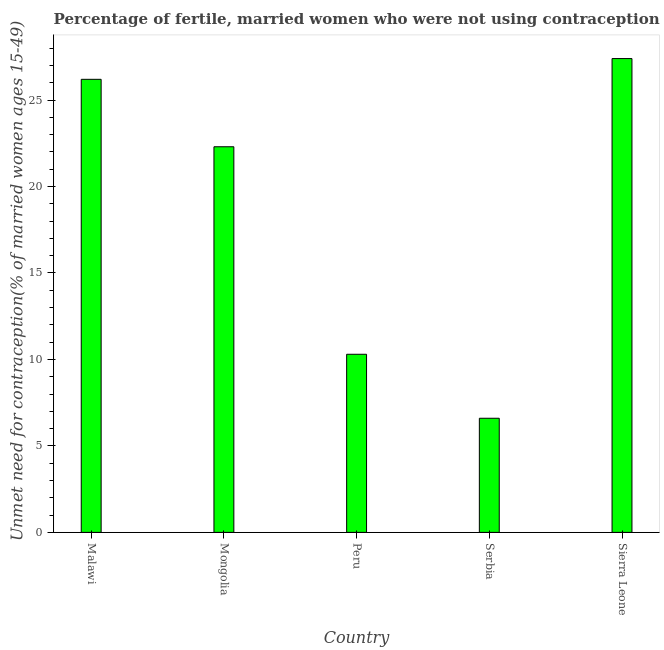Does the graph contain any zero values?
Offer a terse response. No. Does the graph contain grids?
Offer a very short reply. No. What is the title of the graph?
Your response must be concise. Percentage of fertile, married women who were not using contraception in 2010. What is the label or title of the Y-axis?
Keep it short and to the point.  Unmet need for contraception(% of married women ages 15-49). What is the number of married women who are not using contraception in Peru?
Offer a very short reply. 10.3. Across all countries, what is the maximum number of married women who are not using contraception?
Make the answer very short. 27.4. Across all countries, what is the minimum number of married women who are not using contraception?
Provide a succinct answer. 6.6. In which country was the number of married women who are not using contraception maximum?
Make the answer very short. Sierra Leone. In which country was the number of married women who are not using contraception minimum?
Your answer should be very brief. Serbia. What is the sum of the number of married women who are not using contraception?
Your response must be concise. 92.8. What is the difference between the number of married women who are not using contraception in Mongolia and Serbia?
Provide a short and direct response. 15.7. What is the average number of married women who are not using contraception per country?
Your response must be concise. 18.56. What is the median number of married women who are not using contraception?
Your answer should be compact. 22.3. In how many countries, is the number of married women who are not using contraception greater than 18 %?
Give a very brief answer. 3. What is the ratio of the number of married women who are not using contraception in Peru to that in Sierra Leone?
Provide a short and direct response. 0.38. Is the number of married women who are not using contraception in Peru less than that in Serbia?
Your answer should be compact. No. What is the difference between the highest and the lowest number of married women who are not using contraception?
Give a very brief answer. 20.8. How many countries are there in the graph?
Give a very brief answer. 5. What is the  Unmet need for contraception(% of married women ages 15-49) of Malawi?
Your answer should be compact. 26.2. What is the  Unmet need for contraception(% of married women ages 15-49) of Mongolia?
Give a very brief answer. 22.3. What is the  Unmet need for contraception(% of married women ages 15-49) in Peru?
Offer a very short reply. 10.3. What is the  Unmet need for contraception(% of married women ages 15-49) in Serbia?
Ensure brevity in your answer.  6.6. What is the  Unmet need for contraception(% of married women ages 15-49) in Sierra Leone?
Your answer should be very brief. 27.4. What is the difference between the  Unmet need for contraception(% of married women ages 15-49) in Malawi and Peru?
Offer a terse response. 15.9. What is the difference between the  Unmet need for contraception(% of married women ages 15-49) in Malawi and Serbia?
Offer a terse response. 19.6. What is the difference between the  Unmet need for contraception(% of married women ages 15-49) in Malawi and Sierra Leone?
Your answer should be very brief. -1.2. What is the difference between the  Unmet need for contraception(% of married women ages 15-49) in Mongolia and Peru?
Your answer should be very brief. 12. What is the difference between the  Unmet need for contraception(% of married women ages 15-49) in Mongolia and Sierra Leone?
Provide a succinct answer. -5.1. What is the difference between the  Unmet need for contraception(% of married women ages 15-49) in Peru and Sierra Leone?
Your answer should be compact. -17.1. What is the difference between the  Unmet need for contraception(% of married women ages 15-49) in Serbia and Sierra Leone?
Keep it short and to the point. -20.8. What is the ratio of the  Unmet need for contraception(% of married women ages 15-49) in Malawi to that in Mongolia?
Your answer should be compact. 1.18. What is the ratio of the  Unmet need for contraception(% of married women ages 15-49) in Malawi to that in Peru?
Your response must be concise. 2.54. What is the ratio of the  Unmet need for contraception(% of married women ages 15-49) in Malawi to that in Serbia?
Your response must be concise. 3.97. What is the ratio of the  Unmet need for contraception(% of married women ages 15-49) in Malawi to that in Sierra Leone?
Provide a short and direct response. 0.96. What is the ratio of the  Unmet need for contraception(% of married women ages 15-49) in Mongolia to that in Peru?
Your answer should be compact. 2.17. What is the ratio of the  Unmet need for contraception(% of married women ages 15-49) in Mongolia to that in Serbia?
Offer a very short reply. 3.38. What is the ratio of the  Unmet need for contraception(% of married women ages 15-49) in Mongolia to that in Sierra Leone?
Provide a short and direct response. 0.81. What is the ratio of the  Unmet need for contraception(% of married women ages 15-49) in Peru to that in Serbia?
Provide a short and direct response. 1.56. What is the ratio of the  Unmet need for contraception(% of married women ages 15-49) in Peru to that in Sierra Leone?
Provide a succinct answer. 0.38. What is the ratio of the  Unmet need for contraception(% of married women ages 15-49) in Serbia to that in Sierra Leone?
Make the answer very short. 0.24. 